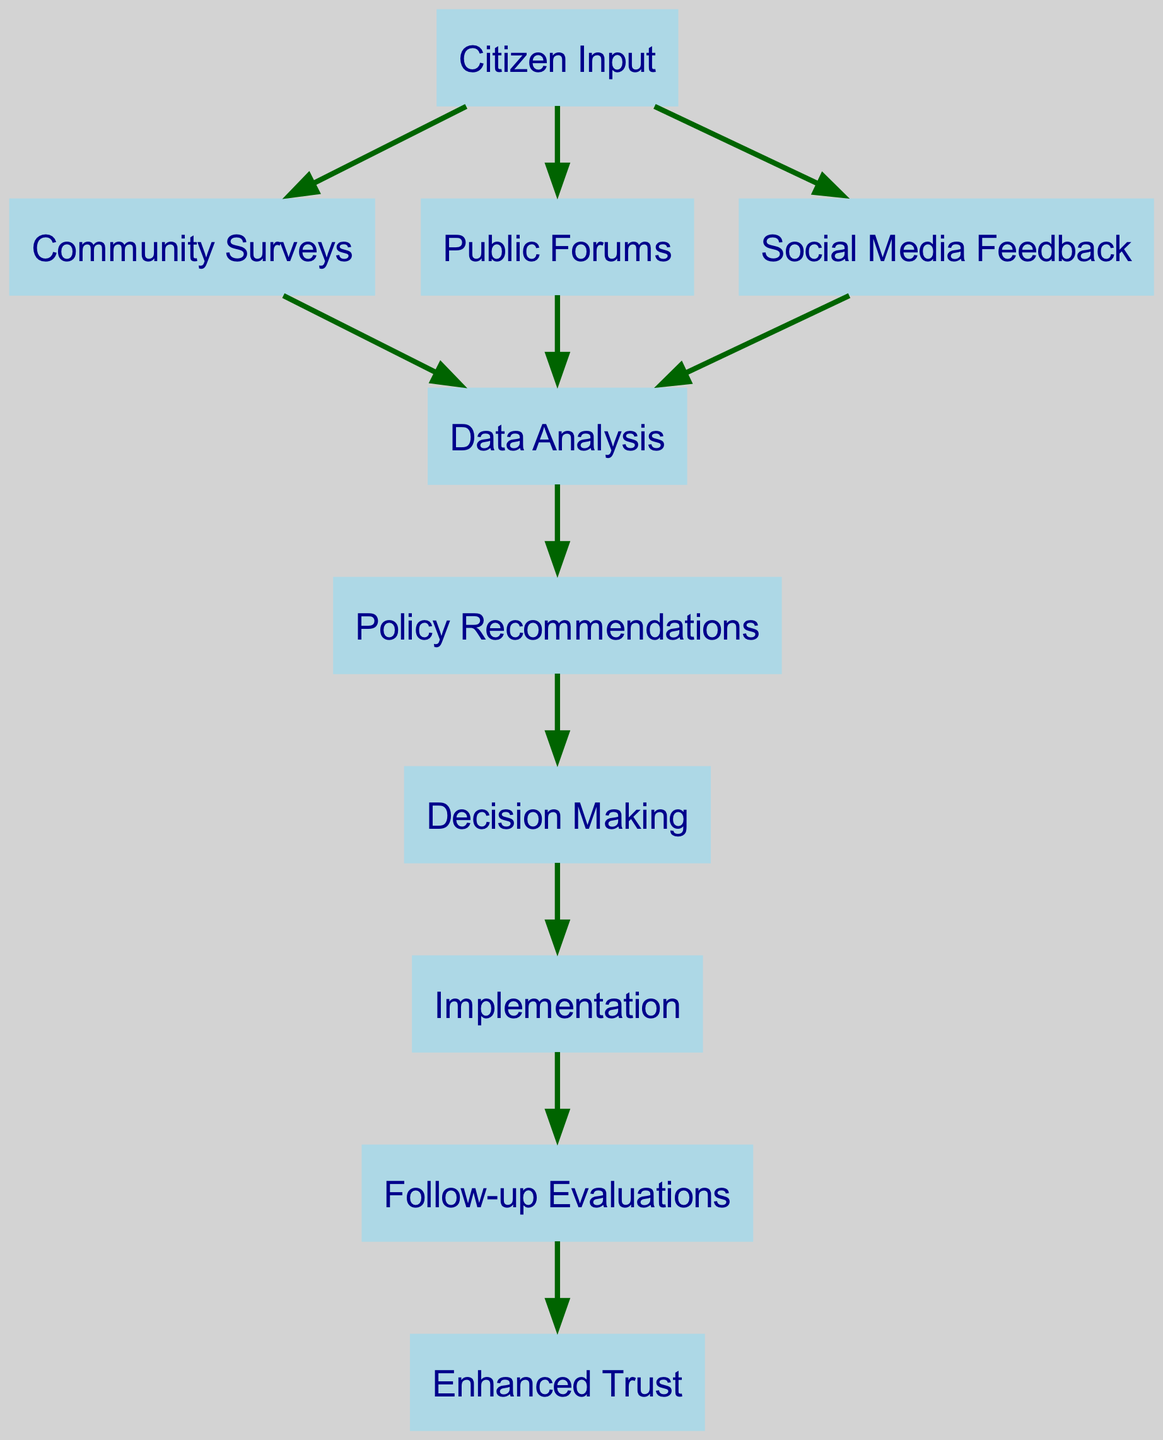What is the first node in the diagram? The first node is "Citizen Input," as it is the starting point from where multiple feedback channels derive.
Answer: Citizen Input How many nodes are in the diagram? There are ten nodes in total, which represent the different stages in the citizen feedback loop.
Answer: 10 What type of feedback does "Community Surveys" lead to? "Community Surveys" leads to "Data Analysis," indicating that information gathered through surveys is analyzed.
Answer: Data Analysis Which node is directly related to "Implementation"? The node that is directly related to "Implementation" is "Decision Making," as it represents the step before implementation occurs.
Answer: Decision Making Which feedback mechanism leads to "Enhanced Trust"? The feedback mechanism leading to "Enhanced Trust" is "Follow-up Evaluations," as it assesses the effectiveness of implementations and further fosters trust.
Answer: Follow-up Evaluations What is the relationship between "Data Analysis" and "Policy Recommendations"? "Data Analysis" informs the creation of "Policy Recommendations," indicating a flow where analyzed data guides the next step in decision-making.
Answer: Policy Recommendations What is the last node in the process? The last node in the process is "Enhanced Trust," which represents the final outcome of the feedback loop.
Answer: Enhanced Trust Identify two nodes that feed into "Data Analysis." "Community Surveys," "Public Forums," and "Social Media Feedback" all feed into "Data Analysis," providing diverse data sources for processing.
Answer: Community Surveys, Public Forums, Social Media Feedback How many edges connect to "Citizen Input"? "Citizen Input" shows three outgoing edges that connect it to "Community Surveys," "Public Forums," and "Social Media Feedback."
Answer: 3 